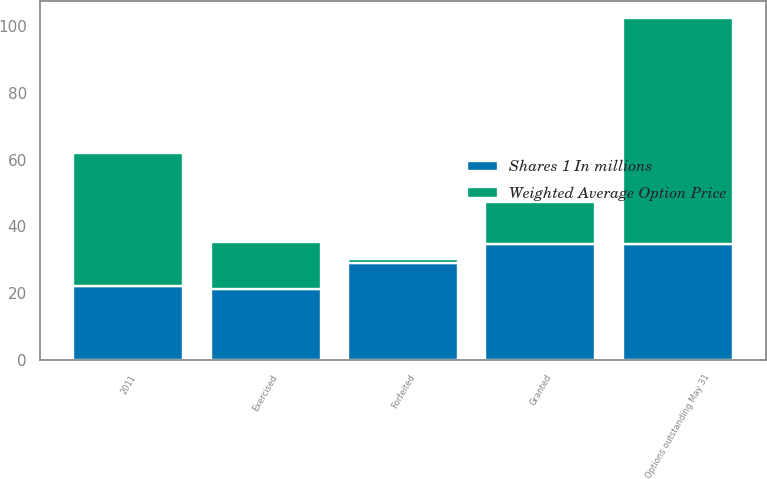<chart> <loc_0><loc_0><loc_500><loc_500><stacked_bar_chart><ecel><fcel>Options outstanding May 31<fcel>Exercised<fcel>Forfeited<fcel>Granted<fcel>2011<nl><fcel>Weighted Average Option Price<fcel>67.7<fcel>14<fcel>1.3<fcel>12.7<fcel>40.1<nl><fcel>Shares 1 In millions<fcel>34.72<fcel>21.35<fcel>29.03<fcel>34.6<fcel>22.03<nl></chart> 